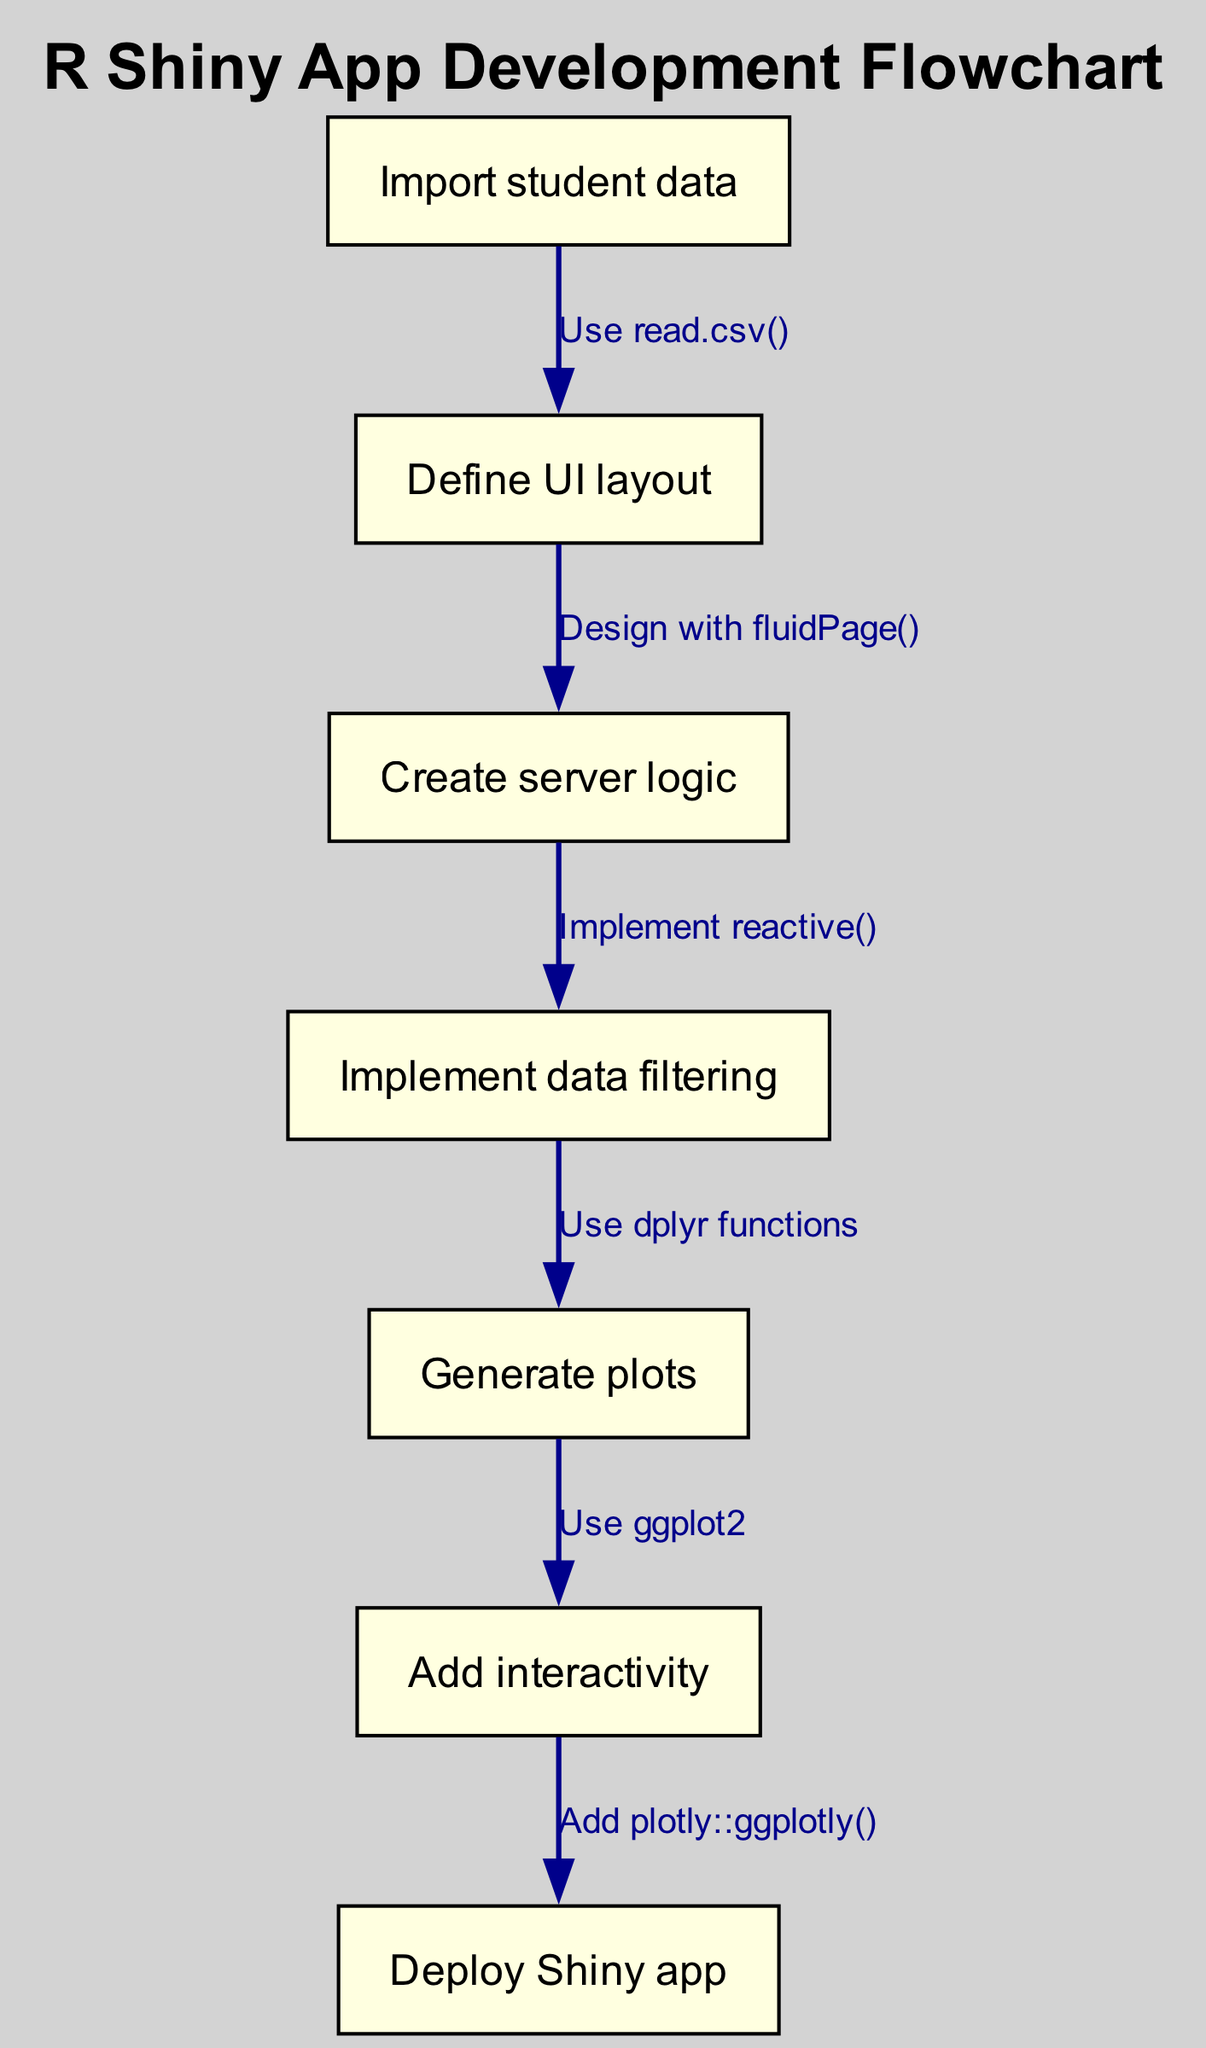What is the first step in developing the R Shiny app? The first step in the flowchart is labeled "Import student data," indicating that this is the initial action required to start the development process.
Answer: Import student data How many nodes are there in the flowchart? By counting the nodes listed in the provided data, there are a total of seven nodes representing different steps in the R Shiny app development process.
Answer: Seven What two actions are connected by the arrow labeled "Use dplyr functions"? The arrow labeled "Use dplyr functions" connects the node "Implement data filtering" to the node "Generate plots," indicating that data filtering is a step before generating plots.
Answer: Implement data filtering and Generate plots Which node follows "Define UI layout"? According to the flowchart, the node that follows "Define UI layout" is "Create server logic," meaning that server logic is created after defining the user interface layout.
Answer: Create server logic What type of interactivity is added before deploying the Shiny app? The diagram indicates that "Add interactivity" occurs as a step before "Deploy Shiny app," implying that adding elements to make the app interactive is necessary before the deployment phase.
Answer: Add interactivity Which function is used to read the student data? The flowchart specifies "Use read.csv()" as the method for importing student data, thus identifying the function responsible for this initial step.
Answer: read.csv() What is the final step in the development process? The last node in the flowchart is "Deploy Shiny app," which indicates that this is the concluding step in the process of developing the app, hence the final action taken.
Answer: Deploy Shiny app Which two nodes are directly connected by the edge labeled "Add plotly::ggplotly()"? The edge labeled "Add plotly::ggplotly()" connects the "Add interactivity" node to the "Deploy Shiny app" node, indicating that adding plotly functionality for interactivity is a prerequisite for deployment.
Answer: Add interactivity and Deploy Shiny app 